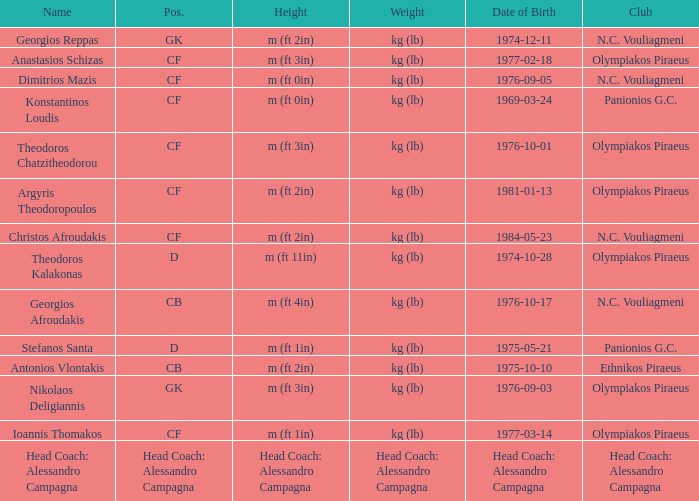What is the weight of the player from club panionios g.c. and was born on 1975-05-21? Kg (lb). Can you parse all the data within this table? {'header': ['Name', 'Pos.', 'Height', 'Weight', 'Date of Birth', 'Club'], 'rows': [['Georgios Reppas', 'GK', 'm (ft 2in)', 'kg (lb)', '1974-12-11', 'N.C. Vouliagmeni'], ['Anastasios Schizas', 'CF', 'm (ft 3in)', 'kg (lb)', '1977-02-18', 'Olympiakos Piraeus'], ['Dimitrios Mazis', 'CF', 'm (ft 0in)', 'kg (lb)', '1976-09-05', 'N.C. Vouliagmeni'], ['Konstantinos Loudis', 'CF', 'm (ft 0in)', 'kg (lb)', '1969-03-24', 'Panionios G.C.'], ['Theodoros Chatzitheodorou', 'CF', 'm (ft 3in)', 'kg (lb)', '1976-10-01', 'Olympiakos Piraeus'], ['Argyris Theodoropoulos', 'CF', 'm (ft 2in)', 'kg (lb)', '1981-01-13', 'Olympiakos Piraeus'], ['Christos Afroudakis', 'CF', 'm (ft 2in)', 'kg (lb)', '1984-05-23', 'N.C. Vouliagmeni'], ['Theodoros Kalakonas', 'D', 'm (ft 11in)', 'kg (lb)', '1974-10-28', 'Olympiakos Piraeus'], ['Georgios Afroudakis', 'CB', 'm (ft 4in)', 'kg (lb)', '1976-10-17', 'N.C. Vouliagmeni'], ['Stefanos Santa', 'D', 'm (ft 1in)', 'kg (lb)', '1975-05-21', 'Panionios G.C.'], ['Antonios Vlontakis', 'CB', 'm (ft 2in)', 'kg (lb)', '1975-10-10', 'Ethnikos Piraeus'], ['Nikolaos Deligiannis', 'GK', 'm (ft 3in)', 'kg (lb)', '1976-09-03', 'Olympiakos Piraeus'], ['Ioannis Thomakos', 'CF', 'm (ft 1in)', 'kg (lb)', '1977-03-14', 'Olympiakos Piraeus'], ['Head Coach: Alessandro Campagna', 'Head Coach: Alessandro Campagna', 'Head Coach: Alessandro Campagna', 'Head Coach: Alessandro Campagna', 'Head Coach: Alessandro Campagna', 'Head Coach: Alessandro Campagna']]} 